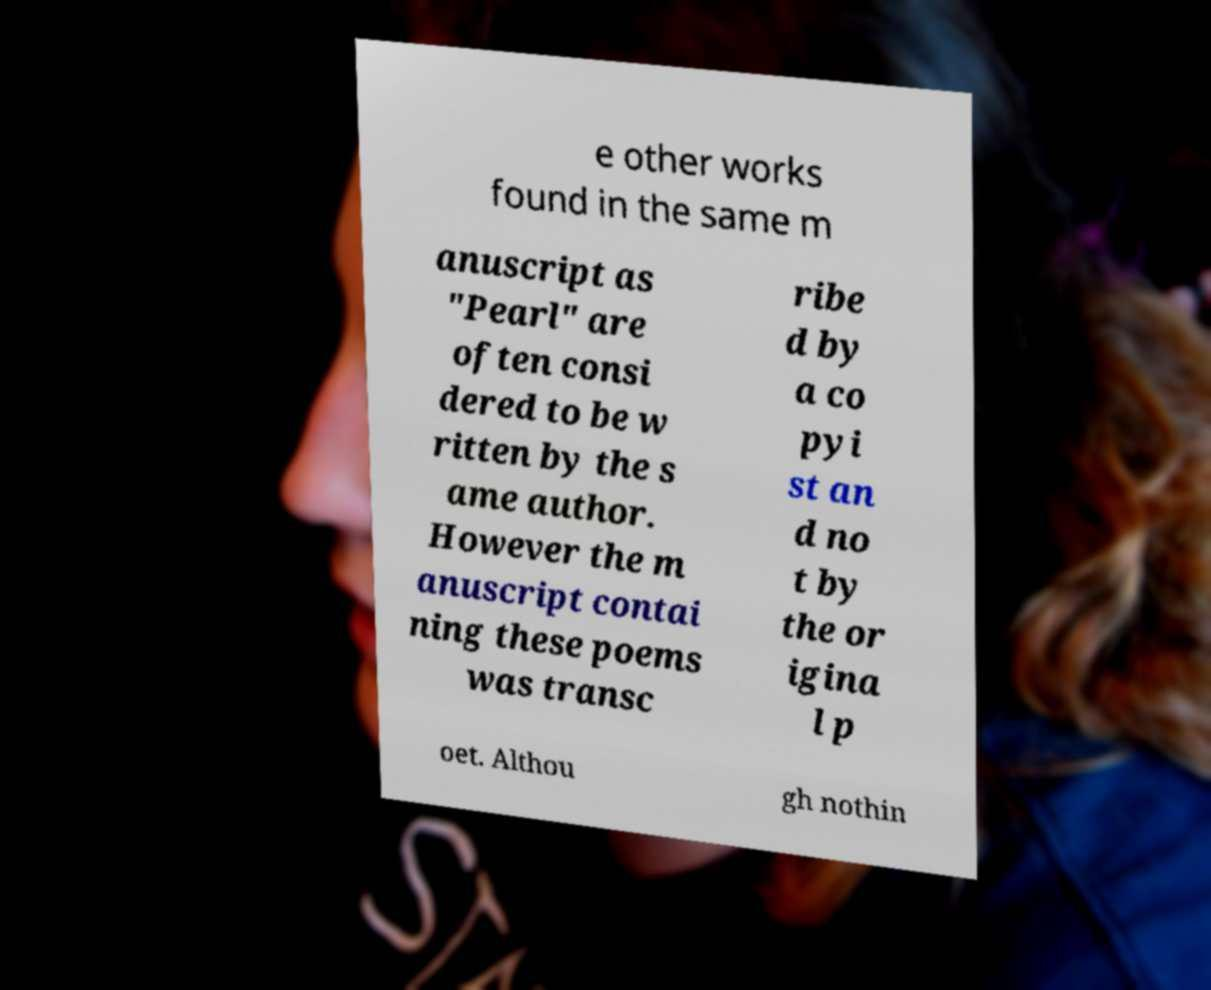Can you read and provide the text displayed in the image?This photo seems to have some interesting text. Can you extract and type it out for me? e other works found in the same m anuscript as "Pearl" are often consi dered to be w ritten by the s ame author. However the m anuscript contai ning these poems was transc ribe d by a co pyi st an d no t by the or igina l p oet. Althou gh nothin 